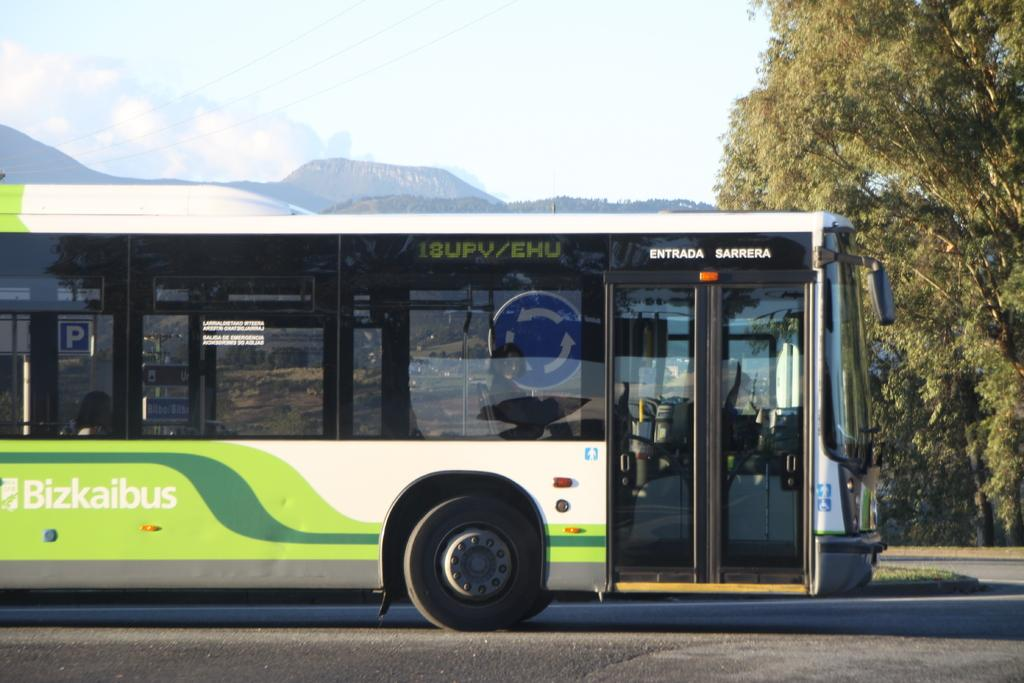<image>
Summarize the visual content of the image. A Bizkaibus, apparently in Spain or another Spanish-speaking country, stopped on a road. 